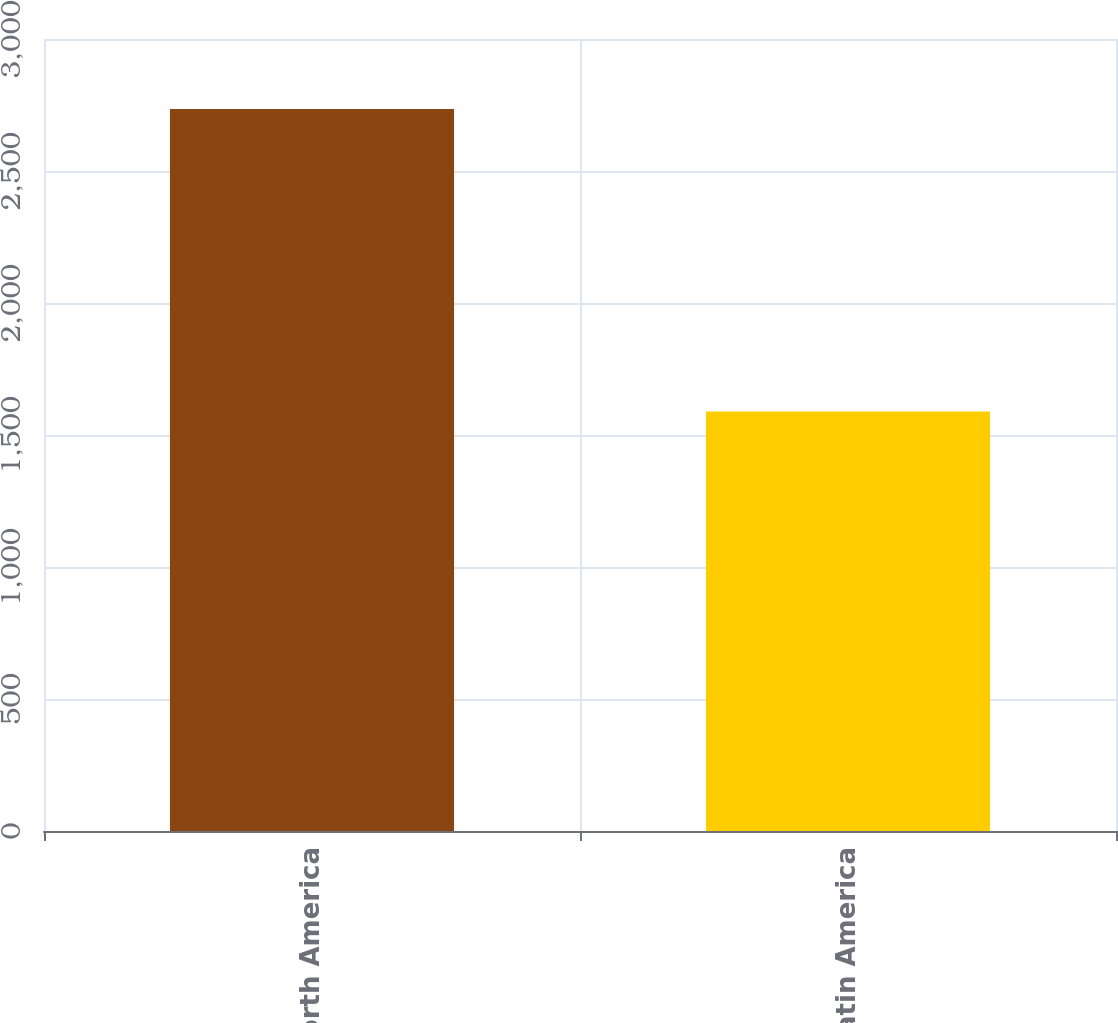<chart> <loc_0><loc_0><loc_500><loc_500><bar_chart><fcel>North America<fcel>Latin America<nl><fcel>2735<fcel>1589<nl></chart> 